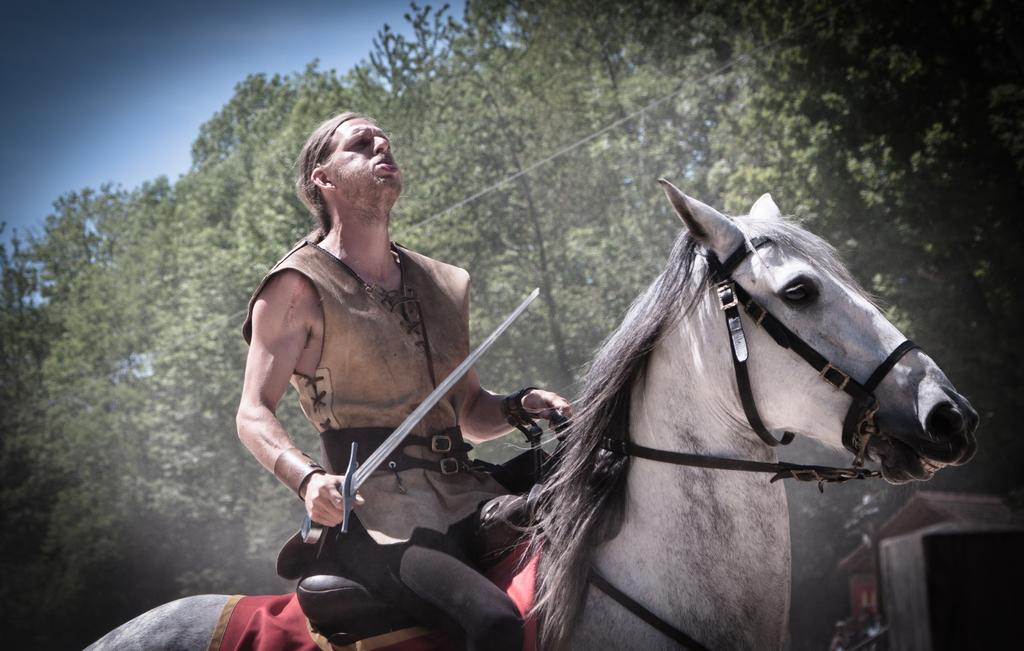What is the main subject of the image? The main subject of the image is a man. What is the man doing in the image? The man is sitting on a horse. What object is the man holding in the image? The man is holding a knife. What color is the man's clothing in the image? The man is wearing brown-colored clothing. What can be seen in the background of the image? There are trees and the sky visible in the background of the image. What type of discussion is taking place between the giants in the image? There are no giants present in the image; it features a man sitting on a horse and holding a knife. How does the wind affect the man's clothing in the image? The image does not provide any information about the wind, so it cannot be determined how it affects the man's clothing. 